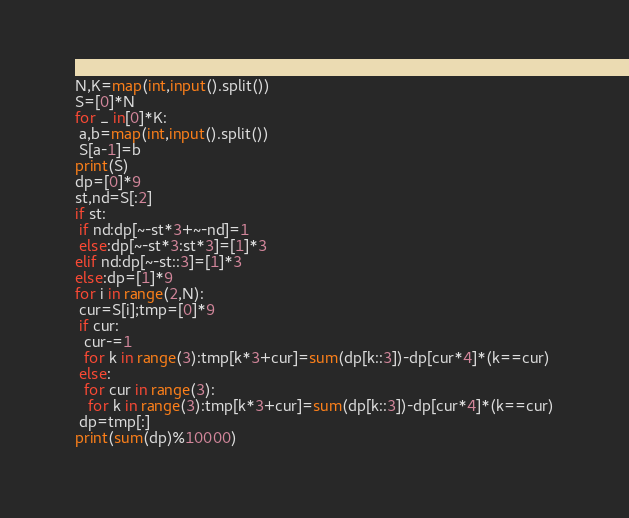<code> <loc_0><loc_0><loc_500><loc_500><_Python_>N,K=map(int,input().split())
S=[0]*N
for _ in[0]*K:
 a,b=map(int,input().split())
 S[a-1]=b
print(S)
dp=[0]*9
st,nd=S[:2]
if st:
 if nd:dp[~-st*3+~-nd]=1
 else:dp[~-st*3:st*3]=[1]*3
elif nd:dp[~-st::3]=[1]*3
else:dp=[1]*9
for i in range(2,N):
 cur=S[i];tmp=[0]*9
 if cur:
  cur-=1
  for k in range(3):tmp[k*3+cur]=sum(dp[k::3])-dp[cur*4]*(k==cur)
 else:
  for cur in range(3):
   for k in range(3):tmp[k*3+cur]=sum(dp[k::3])-dp[cur*4]*(k==cur)
 dp=tmp[:]
print(sum(dp)%10000)
</code> 